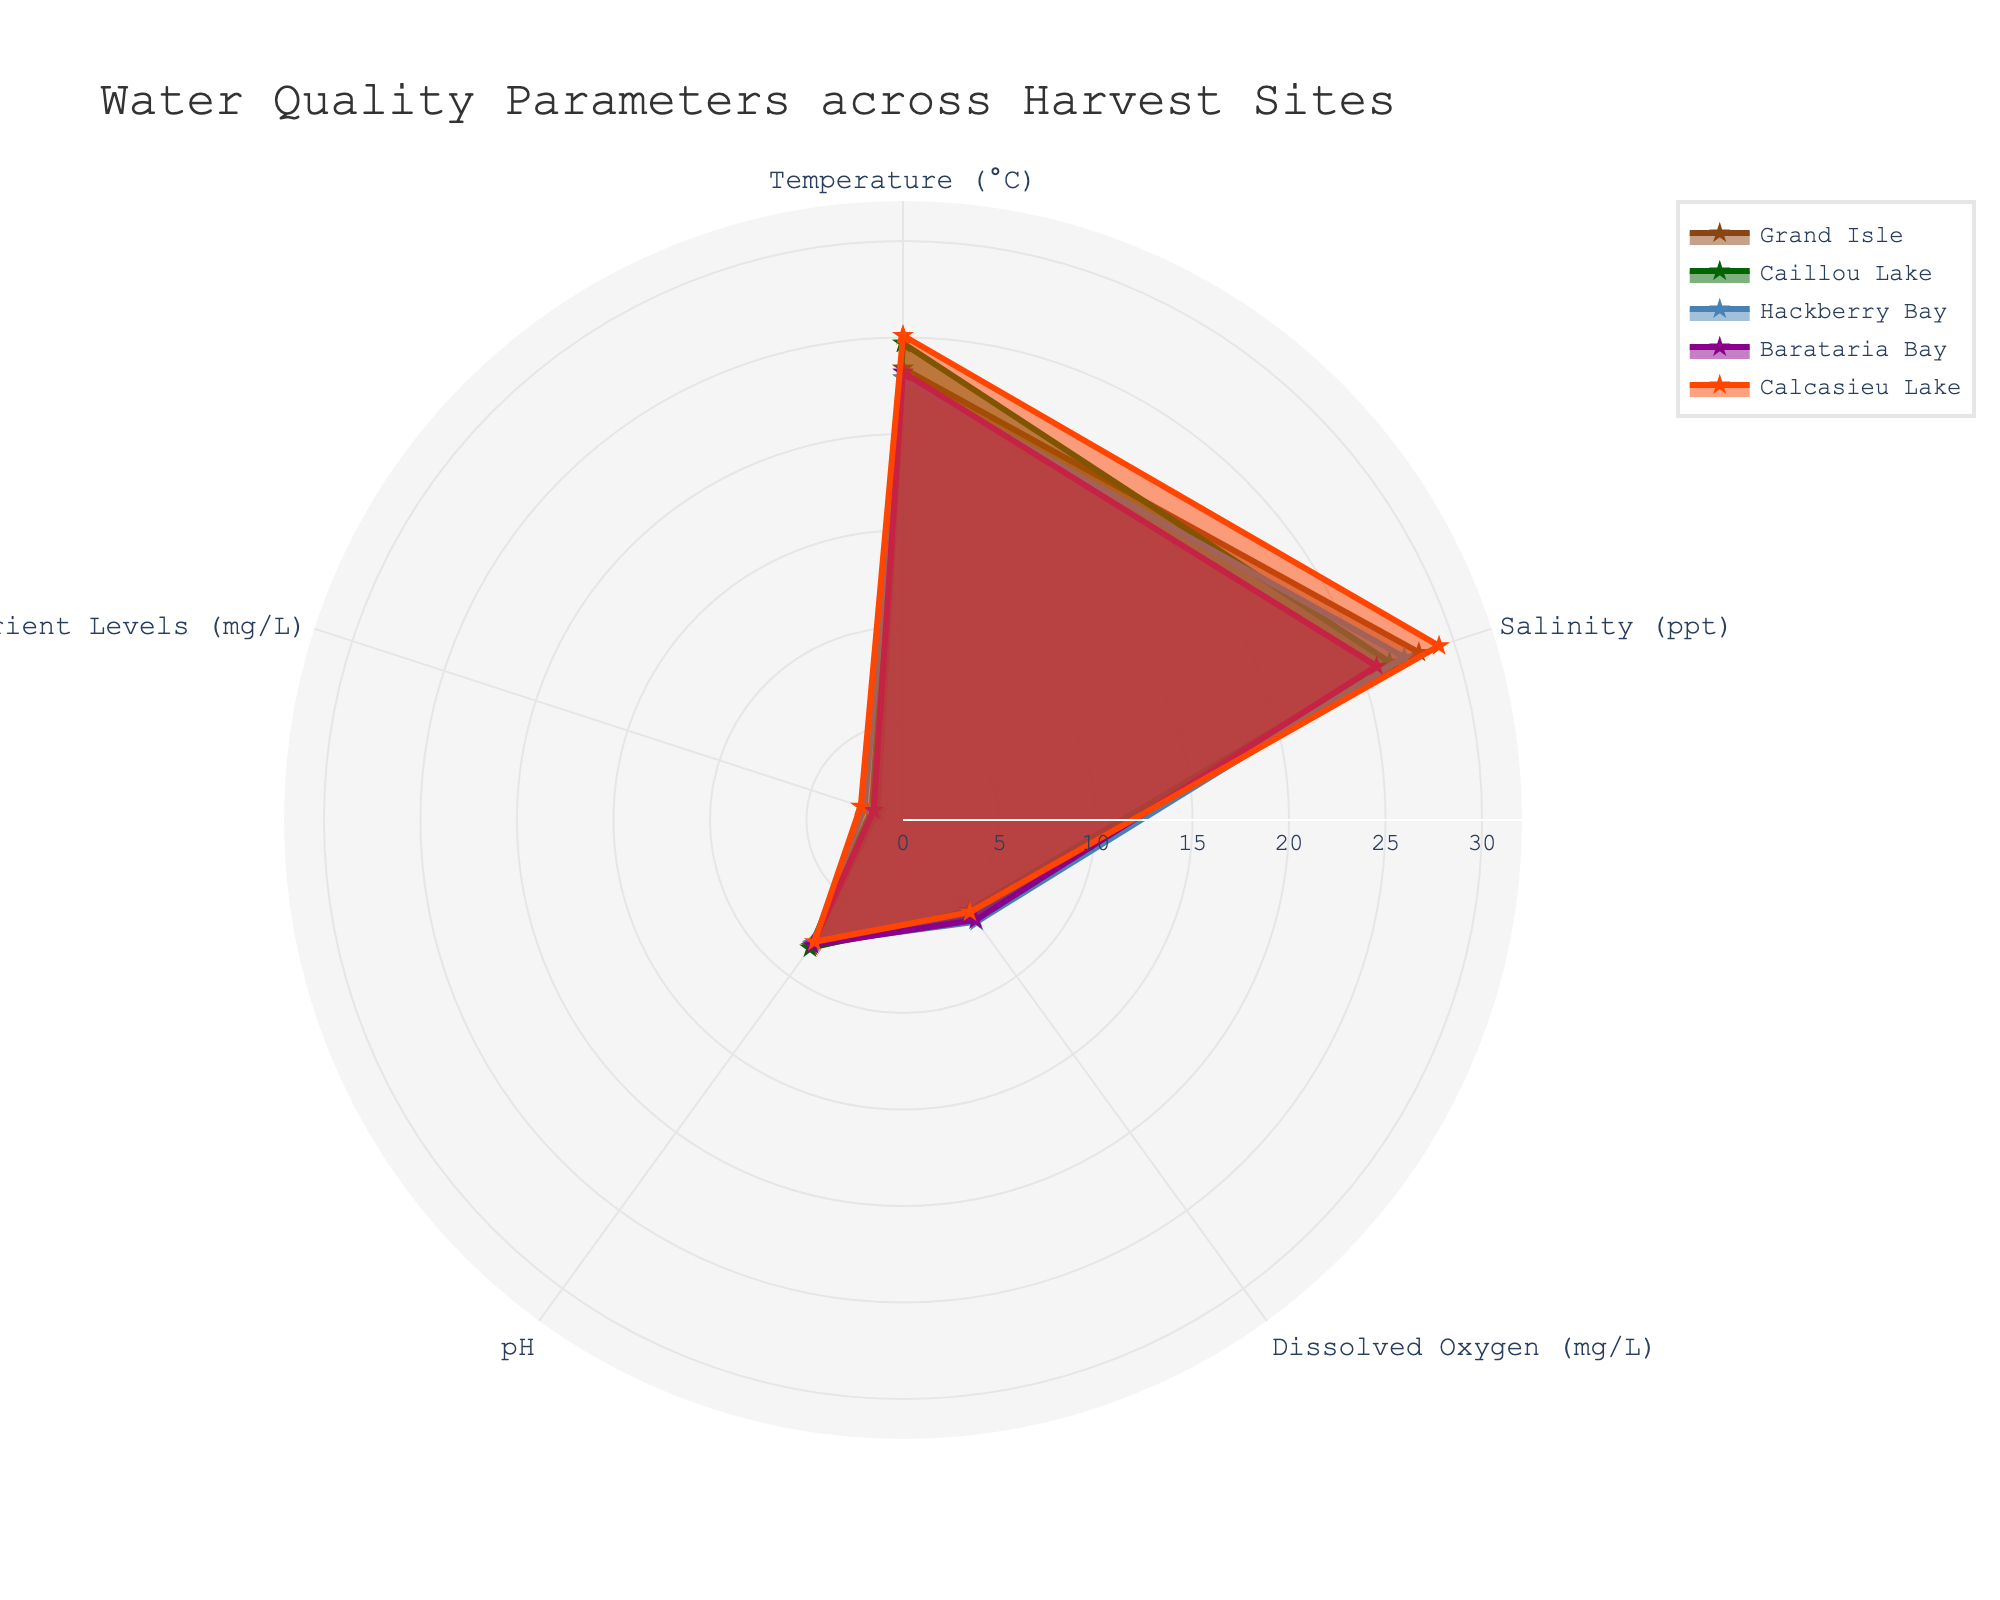What is the title of the figure? The title of the figure is located at the top of the chart, describing what the figure is about.
Answer: 'Water Quality Parameters across Harvest Sites' Which site has the highest temperature value? Examine the 'Temperature (°C)' parameter on the radar chart and identify which site's value reaches the highest peak.
Answer: Calcasieu Lake Which site exhibits the lowest pH level? Look at the 'pH' parameter on the radar chart and identify which site's value is the lowest point among others.
Answer: Calcasieu Lake How many water quality parameters are being compared in the chart? Count the distinct segments along the circle representing different parameters on the radar chart.
Answer: 5 Among the sites, which one has the most balanced water quality parameters? Observe the radar chart and identify the site whose polygon has the most uniform distance from the center in all categories.
Answer: Grand Isle Which sites have a similar trend in 'Salinity (ppt)'? Compare the 'Salinity (ppt)' values for each site, focusing on the points where the different site's curves for salinity intersect or run parallel closely.
Answer: Grand Isle and Hackberry Bay What is the range of 'Dissolved Oxygen (mg/L)' across all sites? Find the minimum and maximum values of 'Dissolved Oxygen' on the radar chart and calculate the difference.
Answer: 0.7 What is the average 'pH' level across all sites? Sum the 'pH' levels of all sites and divide by the number of sites.
Answer: 8.0 Which site shows the largest variance in its water quality parameters? Identify the site with the largest spread from the center of the radar chart to the outer points in its individual polygon.
Answer: Calcasieu Lake Compare 'Nutrient Levels (mg/L)' for Hackberry Bay and Barataria Bay. Which one is higher? Look at the 'Nutrient Levels (mg/L)' values for both Hackberry Bay and Barataria Bay on the radar chart and identify the higher value.
Answer: Hackberry Bay 